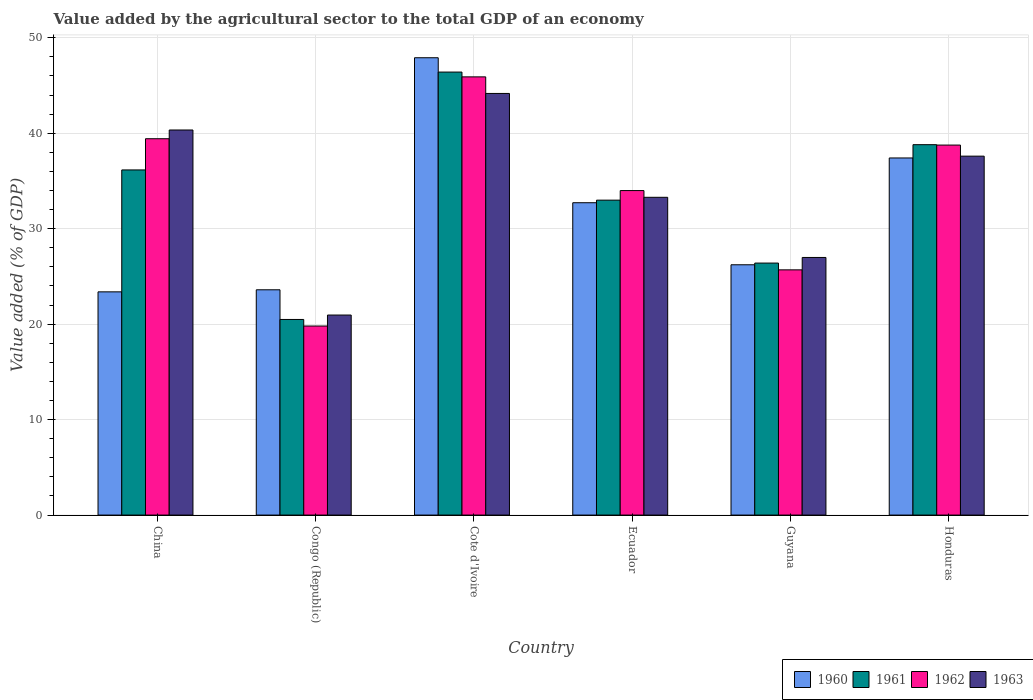How many different coloured bars are there?
Your answer should be compact. 4. How many groups of bars are there?
Your answer should be very brief. 6. Are the number of bars per tick equal to the number of legend labels?
Your response must be concise. Yes. How many bars are there on the 4th tick from the left?
Provide a short and direct response. 4. How many bars are there on the 5th tick from the right?
Offer a very short reply. 4. What is the label of the 4th group of bars from the left?
Your answer should be very brief. Ecuador. In how many cases, is the number of bars for a given country not equal to the number of legend labels?
Provide a succinct answer. 0. What is the value added by the agricultural sector to the total GDP in 1960 in Cote d'Ivoire?
Offer a terse response. 47.91. Across all countries, what is the maximum value added by the agricultural sector to the total GDP in 1963?
Your response must be concise. 44.17. Across all countries, what is the minimum value added by the agricultural sector to the total GDP in 1962?
Ensure brevity in your answer.  19.8. In which country was the value added by the agricultural sector to the total GDP in 1960 maximum?
Your answer should be compact. Cote d'Ivoire. In which country was the value added by the agricultural sector to the total GDP in 1962 minimum?
Your answer should be compact. Congo (Republic). What is the total value added by the agricultural sector to the total GDP in 1961 in the graph?
Keep it short and to the point. 201.24. What is the difference between the value added by the agricultural sector to the total GDP in 1960 in Congo (Republic) and that in Cote d'Ivoire?
Your response must be concise. -24.31. What is the difference between the value added by the agricultural sector to the total GDP in 1963 in Cote d'Ivoire and the value added by the agricultural sector to the total GDP in 1960 in Congo (Republic)?
Your answer should be very brief. 20.57. What is the average value added by the agricultural sector to the total GDP in 1963 per country?
Provide a short and direct response. 33.89. What is the difference between the value added by the agricultural sector to the total GDP of/in 1963 and value added by the agricultural sector to the total GDP of/in 1961 in Guyana?
Give a very brief answer. 0.59. In how many countries, is the value added by the agricultural sector to the total GDP in 1961 greater than 40 %?
Your answer should be very brief. 1. What is the ratio of the value added by the agricultural sector to the total GDP in 1960 in Congo (Republic) to that in Ecuador?
Your response must be concise. 0.72. Is the difference between the value added by the agricultural sector to the total GDP in 1963 in Ecuador and Honduras greater than the difference between the value added by the agricultural sector to the total GDP in 1961 in Ecuador and Honduras?
Your answer should be very brief. Yes. What is the difference between the highest and the second highest value added by the agricultural sector to the total GDP in 1963?
Your response must be concise. -3.83. What is the difference between the highest and the lowest value added by the agricultural sector to the total GDP in 1963?
Make the answer very short. 23.21. Is the sum of the value added by the agricultural sector to the total GDP in 1961 in Congo (Republic) and Honduras greater than the maximum value added by the agricultural sector to the total GDP in 1960 across all countries?
Your answer should be very brief. Yes. Is it the case that in every country, the sum of the value added by the agricultural sector to the total GDP in 1962 and value added by the agricultural sector to the total GDP in 1960 is greater than the sum of value added by the agricultural sector to the total GDP in 1963 and value added by the agricultural sector to the total GDP in 1961?
Provide a short and direct response. No. What does the 3rd bar from the left in Ecuador represents?
Provide a short and direct response. 1962. Are all the bars in the graph horizontal?
Your answer should be compact. No. How many countries are there in the graph?
Make the answer very short. 6. Are the values on the major ticks of Y-axis written in scientific E-notation?
Your answer should be compact. No. Does the graph contain grids?
Give a very brief answer. Yes. Where does the legend appear in the graph?
Keep it short and to the point. Bottom right. How many legend labels are there?
Your answer should be very brief. 4. What is the title of the graph?
Offer a terse response. Value added by the agricultural sector to the total GDP of an economy. Does "1989" appear as one of the legend labels in the graph?
Offer a very short reply. No. What is the label or title of the Y-axis?
Offer a terse response. Value added (% of GDP). What is the Value added (% of GDP) of 1960 in China?
Provide a short and direct response. 23.38. What is the Value added (% of GDP) of 1961 in China?
Keep it short and to the point. 36.16. What is the Value added (% of GDP) in 1962 in China?
Offer a terse response. 39.42. What is the Value added (% of GDP) of 1963 in China?
Make the answer very short. 40.34. What is the Value added (% of GDP) in 1960 in Congo (Republic)?
Make the answer very short. 23.6. What is the Value added (% of GDP) of 1961 in Congo (Republic)?
Keep it short and to the point. 20.49. What is the Value added (% of GDP) of 1962 in Congo (Republic)?
Give a very brief answer. 19.8. What is the Value added (% of GDP) of 1963 in Congo (Republic)?
Ensure brevity in your answer.  20.95. What is the Value added (% of GDP) in 1960 in Cote d'Ivoire?
Your answer should be very brief. 47.91. What is the Value added (% of GDP) in 1961 in Cote d'Ivoire?
Your response must be concise. 46.41. What is the Value added (% of GDP) in 1962 in Cote d'Ivoire?
Offer a very short reply. 45.9. What is the Value added (% of GDP) in 1963 in Cote d'Ivoire?
Keep it short and to the point. 44.17. What is the Value added (% of GDP) in 1960 in Ecuador?
Give a very brief answer. 32.72. What is the Value added (% of GDP) of 1961 in Ecuador?
Your response must be concise. 32.99. What is the Value added (% of GDP) of 1962 in Ecuador?
Provide a short and direct response. 33.99. What is the Value added (% of GDP) in 1963 in Ecuador?
Offer a very short reply. 33.29. What is the Value added (% of GDP) in 1960 in Guyana?
Make the answer very short. 26.22. What is the Value added (% of GDP) of 1961 in Guyana?
Offer a terse response. 26.4. What is the Value added (% of GDP) of 1962 in Guyana?
Provide a short and direct response. 25.69. What is the Value added (% of GDP) of 1963 in Guyana?
Give a very brief answer. 26.99. What is the Value added (% of GDP) of 1960 in Honduras?
Keep it short and to the point. 37.41. What is the Value added (% of GDP) in 1961 in Honduras?
Ensure brevity in your answer.  38.8. What is the Value added (% of GDP) in 1962 in Honduras?
Your answer should be compact. 38.76. What is the Value added (% of GDP) in 1963 in Honduras?
Your response must be concise. 37.6. Across all countries, what is the maximum Value added (% of GDP) of 1960?
Give a very brief answer. 47.91. Across all countries, what is the maximum Value added (% of GDP) of 1961?
Ensure brevity in your answer.  46.41. Across all countries, what is the maximum Value added (% of GDP) of 1962?
Keep it short and to the point. 45.9. Across all countries, what is the maximum Value added (% of GDP) of 1963?
Provide a short and direct response. 44.17. Across all countries, what is the minimum Value added (% of GDP) of 1960?
Offer a terse response. 23.38. Across all countries, what is the minimum Value added (% of GDP) in 1961?
Your response must be concise. 20.49. Across all countries, what is the minimum Value added (% of GDP) in 1962?
Provide a short and direct response. 19.8. Across all countries, what is the minimum Value added (% of GDP) of 1963?
Provide a succinct answer. 20.95. What is the total Value added (% of GDP) of 1960 in the graph?
Provide a short and direct response. 191.24. What is the total Value added (% of GDP) of 1961 in the graph?
Make the answer very short. 201.24. What is the total Value added (% of GDP) of 1962 in the graph?
Your answer should be compact. 203.58. What is the total Value added (% of GDP) in 1963 in the graph?
Your answer should be very brief. 203.33. What is the difference between the Value added (% of GDP) in 1960 in China and that in Congo (Republic)?
Your answer should be very brief. -0.22. What is the difference between the Value added (% of GDP) of 1961 in China and that in Congo (Republic)?
Provide a succinct answer. 15.66. What is the difference between the Value added (% of GDP) in 1962 in China and that in Congo (Republic)?
Offer a terse response. 19.62. What is the difference between the Value added (% of GDP) in 1963 in China and that in Congo (Republic)?
Offer a very short reply. 19.38. What is the difference between the Value added (% of GDP) of 1960 in China and that in Cote d'Ivoire?
Offer a terse response. -24.52. What is the difference between the Value added (% of GDP) in 1961 in China and that in Cote d'Ivoire?
Offer a very short reply. -10.25. What is the difference between the Value added (% of GDP) of 1962 in China and that in Cote d'Ivoire?
Your response must be concise. -6.48. What is the difference between the Value added (% of GDP) of 1963 in China and that in Cote d'Ivoire?
Ensure brevity in your answer.  -3.83. What is the difference between the Value added (% of GDP) in 1960 in China and that in Ecuador?
Make the answer very short. -9.34. What is the difference between the Value added (% of GDP) of 1961 in China and that in Ecuador?
Provide a short and direct response. 3.17. What is the difference between the Value added (% of GDP) of 1962 in China and that in Ecuador?
Offer a very short reply. 5.43. What is the difference between the Value added (% of GDP) in 1963 in China and that in Ecuador?
Keep it short and to the point. 7.05. What is the difference between the Value added (% of GDP) of 1960 in China and that in Guyana?
Provide a short and direct response. -2.84. What is the difference between the Value added (% of GDP) of 1961 in China and that in Guyana?
Make the answer very short. 9.76. What is the difference between the Value added (% of GDP) in 1962 in China and that in Guyana?
Your response must be concise. 13.74. What is the difference between the Value added (% of GDP) in 1963 in China and that in Guyana?
Provide a short and direct response. 13.35. What is the difference between the Value added (% of GDP) of 1960 in China and that in Honduras?
Provide a succinct answer. -14.03. What is the difference between the Value added (% of GDP) of 1961 in China and that in Honduras?
Ensure brevity in your answer.  -2.65. What is the difference between the Value added (% of GDP) of 1962 in China and that in Honduras?
Your answer should be very brief. 0.66. What is the difference between the Value added (% of GDP) in 1963 in China and that in Honduras?
Offer a very short reply. 2.74. What is the difference between the Value added (% of GDP) in 1960 in Congo (Republic) and that in Cote d'Ivoire?
Make the answer very short. -24.31. What is the difference between the Value added (% of GDP) in 1961 in Congo (Republic) and that in Cote d'Ivoire?
Your response must be concise. -25.91. What is the difference between the Value added (% of GDP) of 1962 in Congo (Republic) and that in Cote d'Ivoire?
Keep it short and to the point. -26.1. What is the difference between the Value added (% of GDP) in 1963 in Congo (Republic) and that in Cote d'Ivoire?
Your response must be concise. -23.21. What is the difference between the Value added (% of GDP) in 1960 in Congo (Republic) and that in Ecuador?
Ensure brevity in your answer.  -9.12. What is the difference between the Value added (% of GDP) of 1961 in Congo (Republic) and that in Ecuador?
Ensure brevity in your answer.  -12.5. What is the difference between the Value added (% of GDP) in 1962 in Congo (Republic) and that in Ecuador?
Ensure brevity in your answer.  -14.19. What is the difference between the Value added (% of GDP) in 1963 in Congo (Republic) and that in Ecuador?
Provide a succinct answer. -12.33. What is the difference between the Value added (% of GDP) of 1960 in Congo (Republic) and that in Guyana?
Keep it short and to the point. -2.62. What is the difference between the Value added (% of GDP) of 1961 in Congo (Republic) and that in Guyana?
Offer a terse response. -5.91. What is the difference between the Value added (% of GDP) of 1962 in Congo (Republic) and that in Guyana?
Keep it short and to the point. -5.88. What is the difference between the Value added (% of GDP) in 1963 in Congo (Republic) and that in Guyana?
Give a very brief answer. -6.03. What is the difference between the Value added (% of GDP) in 1960 in Congo (Republic) and that in Honduras?
Your answer should be compact. -13.81. What is the difference between the Value added (% of GDP) in 1961 in Congo (Republic) and that in Honduras?
Your response must be concise. -18.31. What is the difference between the Value added (% of GDP) in 1962 in Congo (Republic) and that in Honduras?
Ensure brevity in your answer.  -18.96. What is the difference between the Value added (% of GDP) in 1963 in Congo (Republic) and that in Honduras?
Provide a short and direct response. -16.65. What is the difference between the Value added (% of GDP) of 1960 in Cote d'Ivoire and that in Ecuador?
Give a very brief answer. 15.19. What is the difference between the Value added (% of GDP) in 1961 in Cote d'Ivoire and that in Ecuador?
Ensure brevity in your answer.  13.42. What is the difference between the Value added (% of GDP) in 1962 in Cote d'Ivoire and that in Ecuador?
Offer a terse response. 11.91. What is the difference between the Value added (% of GDP) of 1963 in Cote d'Ivoire and that in Ecuador?
Keep it short and to the point. 10.88. What is the difference between the Value added (% of GDP) in 1960 in Cote d'Ivoire and that in Guyana?
Your response must be concise. 21.69. What is the difference between the Value added (% of GDP) in 1961 in Cote d'Ivoire and that in Guyana?
Your answer should be compact. 20.01. What is the difference between the Value added (% of GDP) in 1962 in Cote d'Ivoire and that in Guyana?
Provide a succinct answer. 20.22. What is the difference between the Value added (% of GDP) of 1963 in Cote d'Ivoire and that in Guyana?
Provide a succinct answer. 17.18. What is the difference between the Value added (% of GDP) of 1960 in Cote d'Ivoire and that in Honduras?
Provide a succinct answer. 10.5. What is the difference between the Value added (% of GDP) in 1961 in Cote d'Ivoire and that in Honduras?
Keep it short and to the point. 7.61. What is the difference between the Value added (% of GDP) in 1962 in Cote d'Ivoire and that in Honduras?
Offer a very short reply. 7.14. What is the difference between the Value added (% of GDP) of 1963 in Cote d'Ivoire and that in Honduras?
Provide a short and direct response. 6.57. What is the difference between the Value added (% of GDP) in 1960 in Ecuador and that in Guyana?
Offer a terse response. 6.5. What is the difference between the Value added (% of GDP) of 1961 in Ecuador and that in Guyana?
Your response must be concise. 6.59. What is the difference between the Value added (% of GDP) in 1962 in Ecuador and that in Guyana?
Provide a succinct answer. 8.31. What is the difference between the Value added (% of GDP) of 1963 in Ecuador and that in Guyana?
Your answer should be very brief. 6.3. What is the difference between the Value added (% of GDP) of 1960 in Ecuador and that in Honduras?
Give a very brief answer. -4.69. What is the difference between the Value added (% of GDP) in 1961 in Ecuador and that in Honduras?
Keep it short and to the point. -5.81. What is the difference between the Value added (% of GDP) of 1962 in Ecuador and that in Honduras?
Your response must be concise. -4.77. What is the difference between the Value added (% of GDP) of 1963 in Ecuador and that in Honduras?
Make the answer very short. -4.31. What is the difference between the Value added (% of GDP) in 1960 in Guyana and that in Honduras?
Your answer should be compact. -11.19. What is the difference between the Value added (% of GDP) of 1961 in Guyana and that in Honduras?
Keep it short and to the point. -12.4. What is the difference between the Value added (% of GDP) in 1962 in Guyana and that in Honduras?
Give a very brief answer. -13.07. What is the difference between the Value added (% of GDP) of 1963 in Guyana and that in Honduras?
Provide a short and direct response. -10.61. What is the difference between the Value added (% of GDP) of 1960 in China and the Value added (% of GDP) of 1961 in Congo (Republic)?
Ensure brevity in your answer.  2.89. What is the difference between the Value added (% of GDP) of 1960 in China and the Value added (% of GDP) of 1962 in Congo (Republic)?
Offer a terse response. 3.58. What is the difference between the Value added (% of GDP) of 1960 in China and the Value added (% of GDP) of 1963 in Congo (Republic)?
Ensure brevity in your answer.  2.43. What is the difference between the Value added (% of GDP) of 1961 in China and the Value added (% of GDP) of 1962 in Congo (Republic)?
Your answer should be very brief. 16.35. What is the difference between the Value added (% of GDP) of 1961 in China and the Value added (% of GDP) of 1963 in Congo (Republic)?
Ensure brevity in your answer.  15.2. What is the difference between the Value added (% of GDP) of 1962 in China and the Value added (% of GDP) of 1963 in Congo (Republic)?
Provide a short and direct response. 18.47. What is the difference between the Value added (% of GDP) of 1960 in China and the Value added (% of GDP) of 1961 in Cote d'Ivoire?
Provide a succinct answer. -23.02. What is the difference between the Value added (% of GDP) in 1960 in China and the Value added (% of GDP) in 1962 in Cote d'Ivoire?
Your answer should be compact. -22.52. What is the difference between the Value added (% of GDP) of 1960 in China and the Value added (% of GDP) of 1963 in Cote d'Ivoire?
Your answer should be compact. -20.78. What is the difference between the Value added (% of GDP) of 1961 in China and the Value added (% of GDP) of 1962 in Cote d'Ivoire?
Give a very brief answer. -9.75. What is the difference between the Value added (% of GDP) in 1961 in China and the Value added (% of GDP) in 1963 in Cote d'Ivoire?
Your response must be concise. -8.01. What is the difference between the Value added (% of GDP) in 1962 in China and the Value added (% of GDP) in 1963 in Cote d'Ivoire?
Your response must be concise. -4.74. What is the difference between the Value added (% of GDP) in 1960 in China and the Value added (% of GDP) in 1961 in Ecuador?
Your answer should be compact. -9.61. What is the difference between the Value added (% of GDP) of 1960 in China and the Value added (% of GDP) of 1962 in Ecuador?
Provide a short and direct response. -10.61. What is the difference between the Value added (% of GDP) in 1960 in China and the Value added (% of GDP) in 1963 in Ecuador?
Offer a terse response. -9.9. What is the difference between the Value added (% of GDP) in 1961 in China and the Value added (% of GDP) in 1962 in Ecuador?
Make the answer very short. 2.16. What is the difference between the Value added (% of GDP) in 1961 in China and the Value added (% of GDP) in 1963 in Ecuador?
Offer a very short reply. 2.87. What is the difference between the Value added (% of GDP) in 1962 in China and the Value added (% of GDP) in 1963 in Ecuador?
Give a very brief answer. 6.14. What is the difference between the Value added (% of GDP) in 1960 in China and the Value added (% of GDP) in 1961 in Guyana?
Ensure brevity in your answer.  -3.01. What is the difference between the Value added (% of GDP) in 1960 in China and the Value added (% of GDP) in 1962 in Guyana?
Provide a short and direct response. -2.3. What is the difference between the Value added (% of GDP) of 1960 in China and the Value added (% of GDP) of 1963 in Guyana?
Provide a succinct answer. -3.6. What is the difference between the Value added (% of GDP) in 1961 in China and the Value added (% of GDP) in 1962 in Guyana?
Ensure brevity in your answer.  10.47. What is the difference between the Value added (% of GDP) of 1961 in China and the Value added (% of GDP) of 1963 in Guyana?
Your answer should be compact. 9.17. What is the difference between the Value added (% of GDP) in 1962 in China and the Value added (% of GDP) in 1963 in Guyana?
Ensure brevity in your answer.  12.44. What is the difference between the Value added (% of GDP) of 1960 in China and the Value added (% of GDP) of 1961 in Honduras?
Ensure brevity in your answer.  -15.42. What is the difference between the Value added (% of GDP) in 1960 in China and the Value added (% of GDP) in 1962 in Honduras?
Provide a succinct answer. -15.38. What is the difference between the Value added (% of GDP) of 1960 in China and the Value added (% of GDP) of 1963 in Honduras?
Your answer should be compact. -14.22. What is the difference between the Value added (% of GDP) of 1961 in China and the Value added (% of GDP) of 1962 in Honduras?
Offer a very short reply. -2.6. What is the difference between the Value added (% of GDP) in 1961 in China and the Value added (% of GDP) in 1963 in Honduras?
Offer a terse response. -1.44. What is the difference between the Value added (% of GDP) in 1962 in China and the Value added (% of GDP) in 1963 in Honduras?
Keep it short and to the point. 1.82. What is the difference between the Value added (% of GDP) of 1960 in Congo (Republic) and the Value added (% of GDP) of 1961 in Cote d'Ivoire?
Offer a very short reply. -22.81. What is the difference between the Value added (% of GDP) in 1960 in Congo (Republic) and the Value added (% of GDP) in 1962 in Cote d'Ivoire?
Keep it short and to the point. -22.3. What is the difference between the Value added (% of GDP) in 1960 in Congo (Republic) and the Value added (% of GDP) in 1963 in Cote d'Ivoire?
Offer a terse response. -20.57. What is the difference between the Value added (% of GDP) in 1961 in Congo (Republic) and the Value added (% of GDP) in 1962 in Cote d'Ivoire?
Keep it short and to the point. -25.41. What is the difference between the Value added (% of GDP) of 1961 in Congo (Republic) and the Value added (% of GDP) of 1963 in Cote d'Ivoire?
Provide a short and direct response. -23.68. What is the difference between the Value added (% of GDP) of 1962 in Congo (Republic) and the Value added (% of GDP) of 1963 in Cote d'Ivoire?
Provide a succinct answer. -24.36. What is the difference between the Value added (% of GDP) in 1960 in Congo (Republic) and the Value added (% of GDP) in 1961 in Ecuador?
Make the answer very short. -9.39. What is the difference between the Value added (% of GDP) of 1960 in Congo (Republic) and the Value added (% of GDP) of 1962 in Ecuador?
Give a very brief answer. -10.39. What is the difference between the Value added (% of GDP) of 1960 in Congo (Republic) and the Value added (% of GDP) of 1963 in Ecuador?
Offer a terse response. -9.69. What is the difference between the Value added (% of GDP) in 1961 in Congo (Republic) and the Value added (% of GDP) in 1962 in Ecuador?
Make the answer very short. -13.5. What is the difference between the Value added (% of GDP) in 1961 in Congo (Republic) and the Value added (% of GDP) in 1963 in Ecuador?
Ensure brevity in your answer.  -12.8. What is the difference between the Value added (% of GDP) in 1962 in Congo (Republic) and the Value added (% of GDP) in 1963 in Ecuador?
Make the answer very short. -13.48. What is the difference between the Value added (% of GDP) in 1960 in Congo (Republic) and the Value added (% of GDP) in 1961 in Guyana?
Provide a succinct answer. -2.8. What is the difference between the Value added (% of GDP) of 1960 in Congo (Republic) and the Value added (% of GDP) of 1962 in Guyana?
Provide a short and direct response. -2.09. What is the difference between the Value added (% of GDP) of 1960 in Congo (Republic) and the Value added (% of GDP) of 1963 in Guyana?
Ensure brevity in your answer.  -3.39. What is the difference between the Value added (% of GDP) of 1961 in Congo (Republic) and the Value added (% of GDP) of 1962 in Guyana?
Your answer should be very brief. -5.2. What is the difference between the Value added (% of GDP) in 1961 in Congo (Republic) and the Value added (% of GDP) in 1963 in Guyana?
Your answer should be very brief. -6.49. What is the difference between the Value added (% of GDP) of 1962 in Congo (Republic) and the Value added (% of GDP) of 1963 in Guyana?
Make the answer very short. -7.18. What is the difference between the Value added (% of GDP) in 1960 in Congo (Republic) and the Value added (% of GDP) in 1961 in Honduras?
Make the answer very short. -15.2. What is the difference between the Value added (% of GDP) of 1960 in Congo (Republic) and the Value added (% of GDP) of 1962 in Honduras?
Make the answer very short. -15.16. What is the difference between the Value added (% of GDP) in 1960 in Congo (Republic) and the Value added (% of GDP) in 1963 in Honduras?
Your response must be concise. -14. What is the difference between the Value added (% of GDP) of 1961 in Congo (Republic) and the Value added (% of GDP) of 1962 in Honduras?
Your answer should be very brief. -18.27. What is the difference between the Value added (% of GDP) in 1961 in Congo (Republic) and the Value added (% of GDP) in 1963 in Honduras?
Ensure brevity in your answer.  -17.11. What is the difference between the Value added (% of GDP) of 1962 in Congo (Republic) and the Value added (% of GDP) of 1963 in Honduras?
Your answer should be very brief. -17.8. What is the difference between the Value added (% of GDP) of 1960 in Cote d'Ivoire and the Value added (% of GDP) of 1961 in Ecuador?
Make the answer very short. 14.92. What is the difference between the Value added (% of GDP) in 1960 in Cote d'Ivoire and the Value added (% of GDP) in 1962 in Ecuador?
Provide a succinct answer. 13.91. What is the difference between the Value added (% of GDP) of 1960 in Cote d'Ivoire and the Value added (% of GDP) of 1963 in Ecuador?
Keep it short and to the point. 14.62. What is the difference between the Value added (% of GDP) of 1961 in Cote d'Ivoire and the Value added (% of GDP) of 1962 in Ecuador?
Provide a short and direct response. 12.41. What is the difference between the Value added (% of GDP) in 1961 in Cote d'Ivoire and the Value added (% of GDP) in 1963 in Ecuador?
Provide a short and direct response. 13.12. What is the difference between the Value added (% of GDP) of 1962 in Cote d'Ivoire and the Value added (% of GDP) of 1963 in Ecuador?
Provide a succinct answer. 12.62. What is the difference between the Value added (% of GDP) in 1960 in Cote d'Ivoire and the Value added (% of GDP) in 1961 in Guyana?
Give a very brief answer. 21.51. What is the difference between the Value added (% of GDP) of 1960 in Cote d'Ivoire and the Value added (% of GDP) of 1962 in Guyana?
Ensure brevity in your answer.  22.22. What is the difference between the Value added (% of GDP) in 1960 in Cote d'Ivoire and the Value added (% of GDP) in 1963 in Guyana?
Make the answer very short. 20.92. What is the difference between the Value added (% of GDP) of 1961 in Cote d'Ivoire and the Value added (% of GDP) of 1962 in Guyana?
Your answer should be compact. 20.72. What is the difference between the Value added (% of GDP) of 1961 in Cote d'Ivoire and the Value added (% of GDP) of 1963 in Guyana?
Make the answer very short. 19.42. What is the difference between the Value added (% of GDP) of 1962 in Cote d'Ivoire and the Value added (% of GDP) of 1963 in Guyana?
Your response must be concise. 18.92. What is the difference between the Value added (% of GDP) in 1960 in Cote d'Ivoire and the Value added (% of GDP) in 1961 in Honduras?
Make the answer very short. 9.11. What is the difference between the Value added (% of GDP) of 1960 in Cote d'Ivoire and the Value added (% of GDP) of 1962 in Honduras?
Offer a very short reply. 9.15. What is the difference between the Value added (% of GDP) of 1960 in Cote d'Ivoire and the Value added (% of GDP) of 1963 in Honduras?
Provide a succinct answer. 10.31. What is the difference between the Value added (% of GDP) in 1961 in Cote d'Ivoire and the Value added (% of GDP) in 1962 in Honduras?
Provide a succinct answer. 7.65. What is the difference between the Value added (% of GDP) in 1961 in Cote d'Ivoire and the Value added (% of GDP) in 1963 in Honduras?
Your answer should be compact. 8.81. What is the difference between the Value added (% of GDP) in 1962 in Cote d'Ivoire and the Value added (% of GDP) in 1963 in Honduras?
Your answer should be very brief. 8.3. What is the difference between the Value added (% of GDP) in 1960 in Ecuador and the Value added (% of GDP) in 1961 in Guyana?
Ensure brevity in your answer.  6.32. What is the difference between the Value added (% of GDP) in 1960 in Ecuador and the Value added (% of GDP) in 1962 in Guyana?
Your response must be concise. 7.03. What is the difference between the Value added (% of GDP) in 1960 in Ecuador and the Value added (% of GDP) in 1963 in Guyana?
Offer a very short reply. 5.73. What is the difference between the Value added (% of GDP) in 1961 in Ecuador and the Value added (% of GDP) in 1962 in Guyana?
Provide a succinct answer. 7.3. What is the difference between the Value added (% of GDP) in 1961 in Ecuador and the Value added (% of GDP) in 1963 in Guyana?
Keep it short and to the point. 6. What is the difference between the Value added (% of GDP) of 1962 in Ecuador and the Value added (% of GDP) of 1963 in Guyana?
Offer a very short reply. 7.01. What is the difference between the Value added (% of GDP) in 1960 in Ecuador and the Value added (% of GDP) in 1961 in Honduras?
Your answer should be very brief. -6.08. What is the difference between the Value added (% of GDP) of 1960 in Ecuador and the Value added (% of GDP) of 1962 in Honduras?
Ensure brevity in your answer.  -6.04. What is the difference between the Value added (% of GDP) in 1960 in Ecuador and the Value added (% of GDP) in 1963 in Honduras?
Ensure brevity in your answer.  -4.88. What is the difference between the Value added (% of GDP) of 1961 in Ecuador and the Value added (% of GDP) of 1962 in Honduras?
Make the answer very short. -5.77. What is the difference between the Value added (% of GDP) of 1961 in Ecuador and the Value added (% of GDP) of 1963 in Honduras?
Your answer should be very brief. -4.61. What is the difference between the Value added (% of GDP) in 1962 in Ecuador and the Value added (% of GDP) in 1963 in Honduras?
Provide a succinct answer. -3.61. What is the difference between the Value added (% of GDP) in 1960 in Guyana and the Value added (% of GDP) in 1961 in Honduras?
Your answer should be compact. -12.58. What is the difference between the Value added (% of GDP) in 1960 in Guyana and the Value added (% of GDP) in 1962 in Honduras?
Offer a terse response. -12.54. What is the difference between the Value added (% of GDP) in 1960 in Guyana and the Value added (% of GDP) in 1963 in Honduras?
Offer a very short reply. -11.38. What is the difference between the Value added (% of GDP) in 1961 in Guyana and the Value added (% of GDP) in 1962 in Honduras?
Offer a terse response. -12.36. What is the difference between the Value added (% of GDP) of 1961 in Guyana and the Value added (% of GDP) of 1963 in Honduras?
Offer a terse response. -11.2. What is the difference between the Value added (% of GDP) of 1962 in Guyana and the Value added (% of GDP) of 1963 in Honduras?
Your answer should be very brief. -11.91. What is the average Value added (% of GDP) of 1960 per country?
Offer a very short reply. 31.87. What is the average Value added (% of GDP) of 1961 per country?
Provide a succinct answer. 33.54. What is the average Value added (% of GDP) in 1962 per country?
Provide a short and direct response. 33.93. What is the average Value added (% of GDP) in 1963 per country?
Give a very brief answer. 33.89. What is the difference between the Value added (% of GDP) in 1960 and Value added (% of GDP) in 1961 in China?
Offer a terse response. -12.77. What is the difference between the Value added (% of GDP) in 1960 and Value added (% of GDP) in 1962 in China?
Provide a short and direct response. -16.04. What is the difference between the Value added (% of GDP) in 1960 and Value added (% of GDP) in 1963 in China?
Provide a short and direct response. -16.96. What is the difference between the Value added (% of GDP) of 1961 and Value added (% of GDP) of 1962 in China?
Ensure brevity in your answer.  -3.27. What is the difference between the Value added (% of GDP) in 1961 and Value added (% of GDP) in 1963 in China?
Keep it short and to the point. -4.18. What is the difference between the Value added (% of GDP) of 1962 and Value added (% of GDP) of 1963 in China?
Your answer should be very brief. -0.91. What is the difference between the Value added (% of GDP) in 1960 and Value added (% of GDP) in 1961 in Congo (Republic)?
Ensure brevity in your answer.  3.11. What is the difference between the Value added (% of GDP) in 1960 and Value added (% of GDP) in 1962 in Congo (Republic)?
Provide a short and direct response. 3.8. What is the difference between the Value added (% of GDP) in 1960 and Value added (% of GDP) in 1963 in Congo (Republic)?
Your response must be concise. 2.65. What is the difference between the Value added (% of GDP) in 1961 and Value added (% of GDP) in 1962 in Congo (Republic)?
Your answer should be compact. 0.69. What is the difference between the Value added (% of GDP) in 1961 and Value added (% of GDP) in 1963 in Congo (Republic)?
Make the answer very short. -0.46. What is the difference between the Value added (% of GDP) in 1962 and Value added (% of GDP) in 1963 in Congo (Republic)?
Ensure brevity in your answer.  -1.15. What is the difference between the Value added (% of GDP) in 1960 and Value added (% of GDP) in 1961 in Cote d'Ivoire?
Provide a succinct answer. 1.5. What is the difference between the Value added (% of GDP) of 1960 and Value added (% of GDP) of 1962 in Cote d'Ivoire?
Make the answer very short. 2. What is the difference between the Value added (% of GDP) of 1960 and Value added (% of GDP) of 1963 in Cote d'Ivoire?
Provide a short and direct response. 3.74. What is the difference between the Value added (% of GDP) of 1961 and Value added (% of GDP) of 1962 in Cote d'Ivoire?
Your answer should be very brief. 0.5. What is the difference between the Value added (% of GDP) of 1961 and Value added (% of GDP) of 1963 in Cote d'Ivoire?
Your response must be concise. 2.24. What is the difference between the Value added (% of GDP) of 1962 and Value added (% of GDP) of 1963 in Cote d'Ivoire?
Keep it short and to the point. 1.74. What is the difference between the Value added (% of GDP) of 1960 and Value added (% of GDP) of 1961 in Ecuador?
Offer a terse response. -0.27. What is the difference between the Value added (% of GDP) in 1960 and Value added (% of GDP) in 1962 in Ecuador?
Your answer should be compact. -1.27. What is the difference between the Value added (% of GDP) of 1960 and Value added (% of GDP) of 1963 in Ecuador?
Your answer should be very brief. -0.57. What is the difference between the Value added (% of GDP) in 1961 and Value added (% of GDP) in 1962 in Ecuador?
Your answer should be very brief. -1. What is the difference between the Value added (% of GDP) of 1961 and Value added (% of GDP) of 1963 in Ecuador?
Offer a very short reply. -0.3. What is the difference between the Value added (% of GDP) in 1962 and Value added (% of GDP) in 1963 in Ecuador?
Make the answer very short. 0.71. What is the difference between the Value added (% of GDP) of 1960 and Value added (% of GDP) of 1961 in Guyana?
Offer a very short reply. -0.18. What is the difference between the Value added (% of GDP) of 1960 and Value added (% of GDP) of 1962 in Guyana?
Provide a short and direct response. 0.53. What is the difference between the Value added (% of GDP) in 1960 and Value added (% of GDP) in 1963 in Guyana?
Keep it short and to the point. -0.77. What is the difference between the Value added (% of GDP) in 1961 and Value added (% of GDP) in 1962 in Guyana?
Offer a terse response. 0.71. What is the difference between the Value added (% of GDP) of 1961 and Value added (% of GDP) of 1963 in Guyana?
Give a very brief answer. -0.59. What is the difference between the Value added (% of GDP) in 1962 and Value added (% of GDP) in 1963 in Guyana?
Offer a very short reply. -1.3. What is the difference between the Value added (% of GDP) of 1960 and Value added (% of GDP) of 1961 in Honduras?
Give a very brief answer. -1.39. What is the difference between the Value added (% of GDP) of 1960 and Value added (% of GDP) of 1962 in Honduras?
Keep it short and to the point. -1.35. What is the difference between the Value added (% of GDP) in 1960 and Value added (% of GDP) in 1963 in Honduras?
Ensure brevity in your answer.  -0.19. What is the difference between the Value added (% of GDP) of 1961 and Value added (% of GDP) of 1962 in Honduras?
Offer a very short reply. 0.04. What is the difference between the Value added (% of GDP) of 1961 and Value added (% of GDP) of 1963 in Honduras?
Provide a succinct answer. 1.2. What is the difference between the Value added (% of GDP) of 1962 and Value added (% of GDP) of 1963 in Honduras?
Your response must be concise. 1.16. What is the ratio of the Value added (% of GDP) of 1960 in China to that in Congo (Republic)?
Offer a terse response. 0.99. What is the ratio of the Value added (% of GDP) in 1961 in China to that in Congo (Republic)?
Provide a short and direct response. 1.76. What is the ratio of the Value added (% of GDP) in 1962 in China to that in Congo (Republic)?
Give a very brief answer. 1.99. What is the ratio of the Value added (% of GDP) of 1963 in China to that in Congo (Republic)?
Provide a short and direct response. 1.93. What is the ratio of the Value added (% of GDP) in 1960 in China to that in Cote d'Ivoire?
Your response must be concise. 0.49. What is the ratio of the Value added (% of GDP) in 1961 in China to that in Cote d'Ivoire?
Give a very brief answer. 0.78. What is the ratio of the Value added (% of GDP) of 1962 in China to that in Cote d'Ivoire?
Offer a terse response. 0.86. What is the ratio of the Value added (% of GDP) of 1963 in China to that in Cote d'Ivoire?
Ensure brevity in your answer.  0.91. What is the ratio of the Value added (% of GDP) of 1960 in China to that in Ecuador?
Offer a very short reply. 0.71. What is the ratio of the Value added (% of GDP) of 1961 in China to that in Ecuador?
Offer a very short reply. 1.1. What is the ratio of the Value added (% of GDP) of 1962 in China to that in Ecuador?
Your answer should be very brief. 1.16. What is the ratio of the Value added (% of GDP) of 1963 in China to that in Ecuador?
Keep it short and to the point. 1.21. What is the ratio of the Value added (% of GDP) in 1960 in China to that in Guyana?
Keep it short and to the point. 0.89. What is the ratio of the Value added (% of GDP) of 1961 in China to that in Guyana?
Give a very brief answer. 1.37. What is the ratio of the Value added (% of GDP) in 1962 in China to that in Guyana?
Your answer should be compact. 1.53. What is the ratio of the Value added (% of GDP) in 1963 in China to that in Guyana?
Your response must be concise. 1.49. What is the ratio of the Value added (% of GDP) in 1960 in China to that in Honduras?
Keep it short and to the point. 0.63. What is the ratio of the Value added (% of GDP) in 1961 in China to that in Honduras?
Give a very brief answer. 0.93. What is the ratio of the Value added (% of GDP) in 1962 in China to that in Honduras?
Your answer should be compact. 1.02. What is the ratio of the Value added (% of GDP) in 1963 in China to that in Honduras?
Give a very brief answer. 1.07. What is the ratio of the Value added (% of GDP) in 1960 in Congo (Republic) to that in Cote d'Ivoire?
Provide a succinct answer. 0.49. What is the ratio of the Value added (% of GDP) of 1961 in Congo (Republic) to that in Cote d'Ivoire?
Your answer should be compact. 0.44. What is the ratio of the Value added (% of GDP) in 1962 in Congo (Republic) to that in Cote d'Ivoire?
Keep it short and to the point. 0.43. What is the ratio of the Value added (% of GDP) of 1963 in Congo (Republic) to that in Cote d'Ivoire?
Offer a very short reply. 0.47. What is the ratio of the Value added (% of GDP) in 1960 in Congo (Republic) to that in Ecuador?
Keep it short and to the point. 0.72. What is the ratio of the Value added (% of GDP) of 1961 in Congo (Republic) to that in Ecuador?
Your answer should be compact. 0.62. What is the ratio of the Value added (% of GDP) of 1962 in Congo (Republic) to that in Ecuador?
Provide a succinct answer. 0.58. What is the ratio of the Value added (% of GDP) in 1963 in Congo (Republic) to that in Ecuador?
Ensure brevity in your answer.  0.63. What is the ratio of the Value added (% of GDP) of 1960 in Congo (Republic) to that in Guyana?
Provide a succinct answer. 0.9. What is the ratio of the Value added (% of GDP) in 1961 in Congo (Republic) to that in Guyana?
Offer a very short reply. 0.78. What is the ratio of the Value added (% of GDP) in 1962 in Congo (Republic) to that in Guyana?
Ensure brevity in your answer.  0.77. What is the ratio of the Value added (% of GDP) of 1963 in Congo (Republic) to that in Guyana?
Give a very brief answer. 0.78. What is the ratio of the Value added (% of GDP) of 1960 in Congo (Republic) to that in Honduras?
Offer a very short reply. 0.63. What is the ratio of the Value added (% of GDP) in 1961 in Congo (Republic) to that in Honduras?
Your response must be concise. 0.53. What is the ratio of the Value added (% of GDP) in 1962 in Congo (Republic) to that in Honduras?
Provide a succinct answer. 0.51. What is the ratio of the Value added (% of GDP) of 1963 in Congo (Republic) to that in Honduras?
Provide a short and direct response. 0.56. What is the ratio of the Value added (% of GDP) of 1960 in Cote d'Ivoire to that in Ecuador?
Provide a succinct answer. 1.46. What is the ratio of the Value added (% of GDP) of 1961 in Cote d'Ivoire to that in Ecuador?
Provide a short and direct response. 1.41. What is the ratio of the Value added (% of GDP) of 1962 in Cote d'Ivoire to that in Ecuador?
Keep it short and to the point. 1.35. What is the ratio of the Value added (% of GDP) in 1963 in Cote d'Ivoire to that in Ecuador?
Your answer should be very brief. 1.33. What is the ratio of the Value added (% of GDP) of 1960 in Cote d'Ivoire to that in Guyana?
Give a very brief answer. 1.83. What is the ratio of the Value added (% of GDP) in 1961 in Cote d'Ivoire to that in Guyana?
Your answer should be compact. 1.76. What is the ratio of the Value added (% of GDP) in 1962 in Cote d'Ivoire to that in Guyana?
Your answer should be very brief. 1.79. What is the ratio of the Value added (% of GDP) of 1963 in Cote d'Ivoire to that in Guyana?
Keep it short and to the point. 1.64. What is the ratio of the Value added (% of GDP) in 1960 in Cote d'Ivoire to that in Honduras?
Give a very brief answer. 1.28. What is the ratio of the Value added (% of GDP) of 1961 in Cote d'Ivoire to that in Honduras?
Your answer should be very brief. 1.2. What is the ratio of the Value added (% of GDP) of 1962 in Cote d'Ivoire to that in Honduras?
Your answer should be compact. 1.18. What is the ratio of the Value added (% of GDP) in 1963 in Cote d'Ivoire to that in Honduras?
Provide a short and direct response. 1.17. What is the ratio of the Value added (% of GDP) in 1960 in Ecuador to that in Guyana?
Your answer should be very brief. 1.25. What is the ratio of the Value added (% of GDP) in 1961 in Ecuador to that in Guyana?
Offer a terse response. 1.25. What is the ratio of the Value added (% of GDP) of 1962 in Ecuador to that in Guyana?
Your answer should be compact. 1.32. What is the ratio of the Value added (% of GDP) in 1963 in Ecuador to that in Guyana?
Give a very brief answer. 1.23. What is the ratio of the Value added (% of GDP) of 1960 in Ecuador to that in Honduras?
Ensure brevity in your answer.  0.87. What is the ratio of the Value added (% of GDP) in 1961 in Ecuador to that in Honduras?
Your answer should be very brief. 0.85. What is the ratio of the Value added (% of GDP) of 1962 in Ecuador to that in Honduras?
Offer a terse response. 0.88. What is the ratio of the Value added (% of GDP) of 1963 in Ecuador to that in Honduras?
Provide a short and direct response. 0.89. What is the ratio of the Value added (% of GDP) of 1960 in Guyana to that in Honduras?
Provide a succinct answer. 0.7. What is the ratio of the Value added (% of GDP) in 1961 in Guyana to that in Honduras?
Ensure brevity in your answer.  0.68. What is the ratio of the Value added (% of GDP) in 1962 in Guyana to that in Honduras?
Provide a short and direct response. 0.66. What is the ratio of the Value added (% of GDP) of 1963 in Guyana to that in Honduras?
Offer a very short reply. 0.72. What is the difference between the highest and the second highest Value added (% of GDP) of 1960?
Your answer should be very brief. 10.5. What is the difference between the highest and the second highest Value added (% of GDP) in 1961?
Your answer should be compact. 7.61. What is the difference between the highest and the second highest Value added (% of GDP) of 1962?
Your answer should be very brief. 6.48. What is the difference between the highest and the second highest Value added (% of GDP) in 1963?
Your response must be concise. 3.83. What is the difference between the highest and the lowest Value added (% of GDP) in 1960?
Provide a short and direct response. 24.52. What is the difference between the highest and the lowest Value added (% of GDP) in 1961?
Ensure brevity in your answer.  25.91. What is the difference between the highest and the lowest Value added (% of GDP) in 1962?
Your response must be concise. 26.1. What is the difference between the highest and the lowest Value added (% of GDP) in 1963?
Provide a succinct answer. 23.21. 